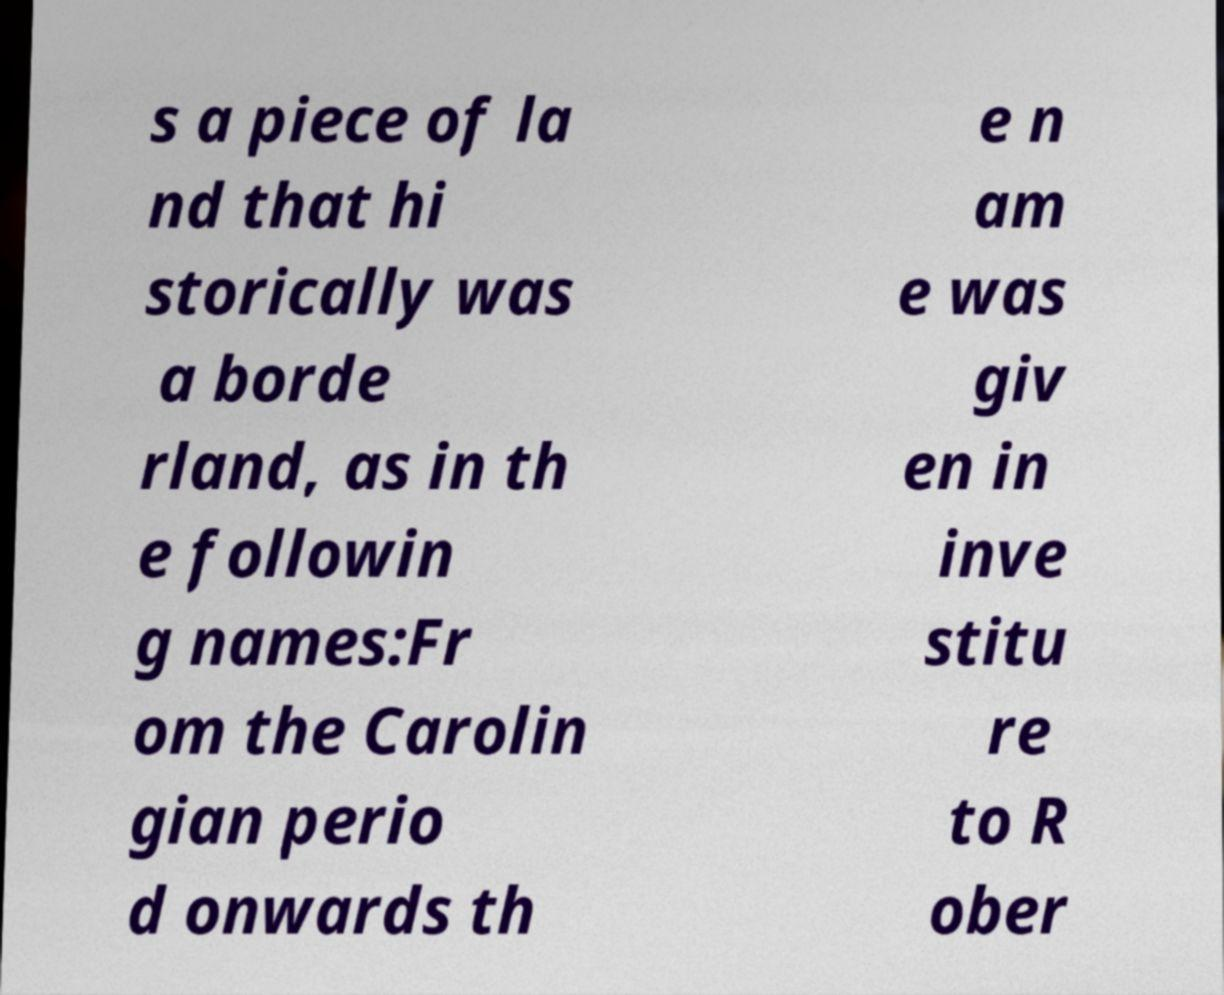Please identify and transcribe the text found in this image. s a piece of la nd that hi storically was a borde rland, as in th e followin g names:Fr om the Carolin gian perio d onwards th e n am e was giv en in inve stitu re to R ober 